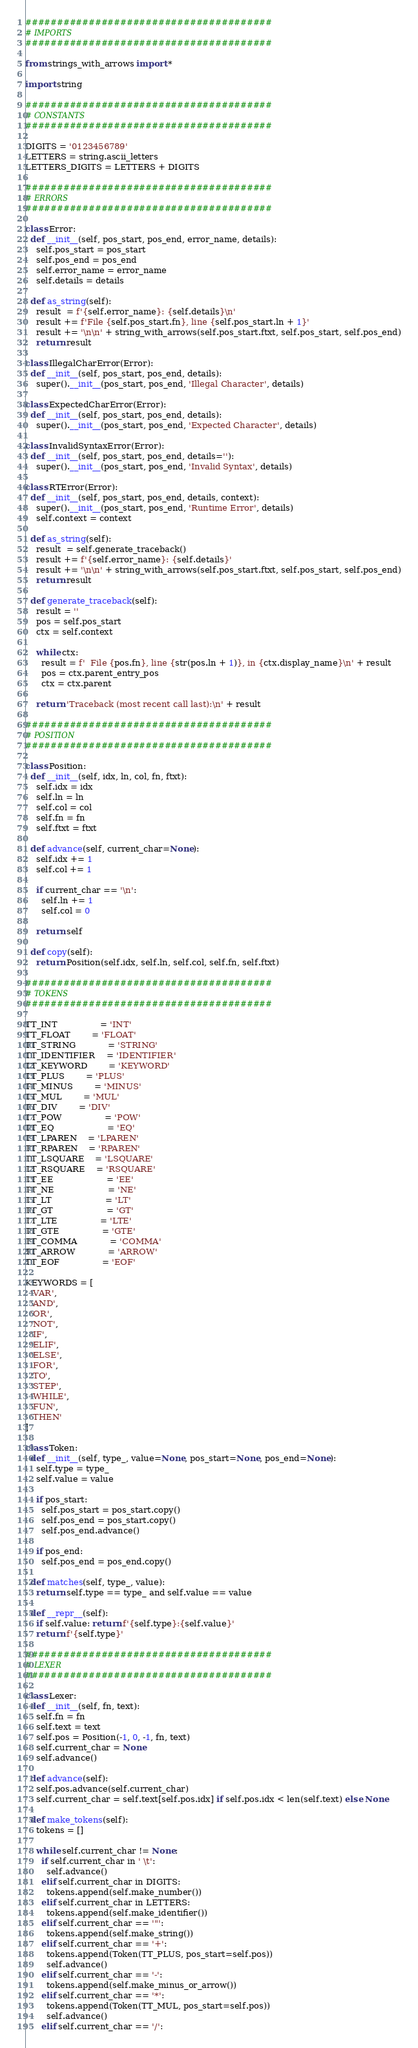Convert code to text. <code><loc_0><loc_0><loc_500><loc_500><_Python_>#######################################
# IMPORTS
#######################################

from strings_with_arrows import *

import string

#######################################
# CONSTANTS
#######################################

DIGITS = '0123456789'
LETTERS = string.ascii_letters
LETTERS_DIGITS = LETTERS + DIGITS

#######################################
# ERRORS
#######################################

class Error:
  def __init__(self, pos_start, pos_end, error_name, details):
    self.pos_start = pos_start
    self.pos_end = pos_end
    self.error_name = error_name
    self.details = details
  
  def as_string(self):
    result  = f'{self.error_name}: {self.details}\n'
    result += f'File {self.pos_start.fn}, line {self.pos_start.ln + 1}'
    result += '\n\n' + string_with_arrows(self.pos_start.ftxt, self.pos_start, self.pos_end)
    return result

class IllegalCharError(Error):
  def __init__(self, pos_start, pos_end, details):
    super().__init__(pos_start, pos_end, 'Illegal Character', details)

class ExpectedCharError(Error):
  def __init__(self, pos_start, pos_end, details):
    super().__init__(pos_start, pos_end, 'Expected Character', details)

class InvalidSyntaxError(Error):
  def __init__(self, pos_start, pos_end, details=''):
    super().__init__(pos_start, pos_end, 'Invalid Syntax', details)

class RTError(Error):
  def __init__(self, pos_start, pos_end, details, context):
    super().__init__(pos_start, pos_end, 'Runtime Error', details)
    self.context = context

  def as_string(self):
    result  = self.generate_traceback()
    result += f'{self.error_name}: {self.details}'
    result += '\n\n' + string_with_arrows(self.pos_start.ftxt, self.pos_start, self.pos_end)
    return result

  def generate_traceback(self):
    result = ''
    pos = self.pos_start
    ctx = self.context

    while ctx:
      result = f'  File {pos.fn}, line {str(pos.ln + 1)}, in {ctx.display_name}\n' + result
      pos = ctx.parent_entry_pos
      ctx = ctx.parent

    return 'Traceback (most recent call last):\n' + result

#######################################
# POSITION
#######################################

class Position:
  def __init__(self, idx, ln, col, fn, ftxt):
    self.idx = idx
    self.ln = ln
    self.col = col
    self.fn = fn
    self.ftxt = ftxt

  def advance(self, current_char=None):
    self.idx += 1
    self.col += 1

    if current_char == '\n':
      self.ln += 1
      self.col = 0

    return self

  def copy(self):
    return Position(self.idx, self.ln, self.col, self.fn, self.ftxt)

#######################################
# TOKENS
#######################################

TT_INT				= 'INT'
TT_FLOAT    	= 'FLOAT'
TT_STRING			= 'STRING'
TT_IDENTIFIER	= 'IDENTIFIER'
TT_KEYWORD		= 'KEYWORD'
TT_PLUS     	= 'PLUS'
TT_MINUS    	= 'MINUS'
TT_MUL      	= 'MUL'
TT_DIV      	= 'DIV'
TT_POW				= 'POW'
TT_EQ					= 'EQ'
TT_LPAREN   	= 'LPAREN'
TT_RPAREN   	= 'RPAREN'
TT_LSQUARE    = 'LSQUARE'
TT_RSQUARE    = 'RSQUARE'
TT_EE					= 'EE'
TT_NE					= 'NE'
TT_LT					= 'LT'
TT_GT					= 'GT'
TT_LTE				= 'LTE'
TT_GTE				= 'GTE'
TT_COMMA			= 'COMMA'
TT_ARROW			= 'ARROW'
TT_EOF				= 'EOF'

KEYWORDS = [
  'VAR',
  'AND',
  'OR',
  'NOT',
  'IF',
  'ELIF',
  'ELSE',
  'FOR',
  'TO',
  'STEP',
  'WHILE',
  'FUN',
  'THEN'
]

class Token:
  def __init__(self, type_, value=None, pos_start=None, pos_end=None):
    self.type = type_
    self.value = value

    if pos_start:
      self.pos_start = pos_start.copy()
      self.pos_end = pos_start.copy()
      self.pos_end.advance()

    if pos_end:
      self.pos_end = pos_end.copy()

  def matches(self, type_, value):
    return self.type == type_ and self.value == value
  
  def __repr__(self):
    if self.value: return f'{self.type}:{self.value}'
    return f'{self.type}'

#######################################
# LEXER
#######################################

class Lexer:
  def __init__(self, fn, text):
    self.fn = fn
    self.text = text
    self.pos = Position(-1, 0, -1, fn, text)
    self.current_char = None
    self.advance()
  
  def advance(self):
    self.pos.advance(self.current_char)
    self.current_char = self.text[self.pos.idx] if self.pos.idx < len(self.text) else None

  def make_tokens(self):
    tokens = []

    while self.current_char != None:
      if self.current_char in ' \t':
        self.advance()
      elif self.current_char in DIGITS:
        tokens.append(self.make_number())
      elif self.current_char in LETTERS:
        tokens.append(self.make_identifier())
      elif self.current_char == '"':
        tokens.append(self.make_string())
      elif self.current_char == '+':
        tokens.append(Token(TT_PLUS, pos_start=self.pos))
        self.advance()
      elif self.current_char == '-':
        tokens.append(self.make_minus_or_arrow())
      elif self.current_char == '*':
        tokens.append(Token(TT_MUL, pos_start=self.pos))
        self.advance()
      elif self.current_char == '/':</code> 